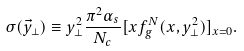Convert formula to latex. <formula><loc_0><loc_0><loc_500><loc_500>\sigma ( \vec { y } _ { \perp } ) \equiv y _ { \perp } ^ { 2 } \frac { \pi ^ { 2 } \alpha _ { s } } { N _ { c } } [ x f _ { g } ^ { N } ( x , y _ { \perp } ^ { 2 } ) ] _ { x = 0 } .</formula> 